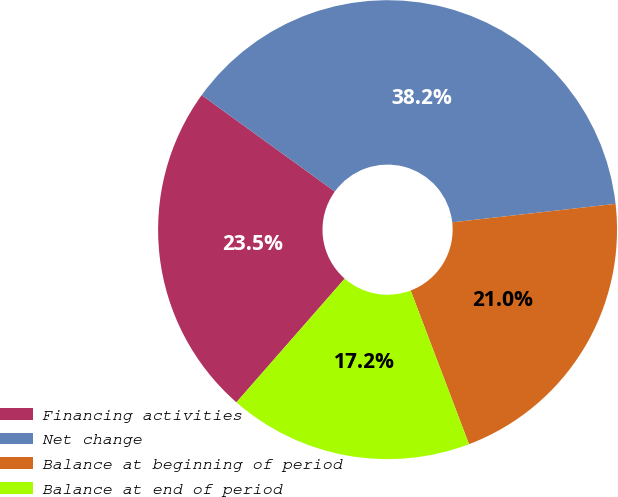Convert chart to OTSL. <chart><loc_0><loc_0><loc_500><loc_500><pie_chart><fcel>Financing activities<fcel>Net change<fcel>Balance at beginning of period<fcel>Balance at end of period<nl><fcel>23.53%<fcel>38.24%<fcel>21.02%<fcel>17.22%<nl></chart> 